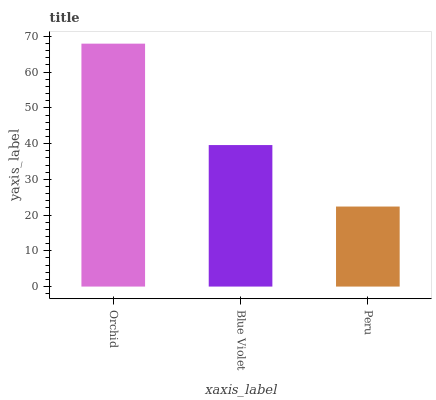Is Peru the minimum?
Answer yes or no. Yes. Is Orchid the maximum?
Answer yes or no. Yes. Is Blue Violet the minimum?
Answer yes or no. No. Is Blue Violet the maximum?
Answer yes or no. No. Is Orchid greater than Blue Violet?
Answer yes or no. Yes. Is Blue Violet less than Orchid?
Answer yes or no. Yes. Is Blue Violet greater than Orchid?
Answer yes or no. No. Is Orchid less than Blue Violet?
Answer yes or no. No. Is Blue Violet the high median?
Answer yes or no. Yes. Is Blue Violet the low median?
Answer yes or no. Yes. Is Orchid the high median?
Answer yes or no. No. Is Orchid the low median?
Answer yes or no. No. 